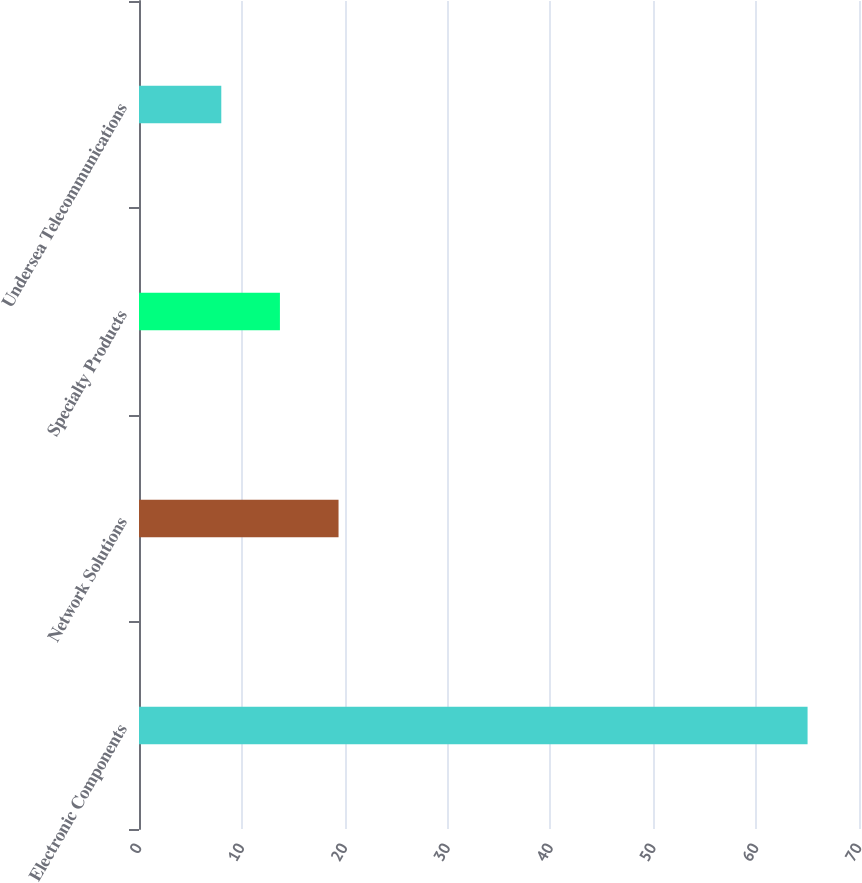<chart> <loc_0><loc_0><loc_500><loc_500><bar_chart><fcel>Electronic Components<fcel>Network Solutions<fcel>Specialty Products<fcel>Undersea Telecommunications<nl><fcel>65<fcel>19.4<fcel>13.7<fcel>8<nl></chart> 